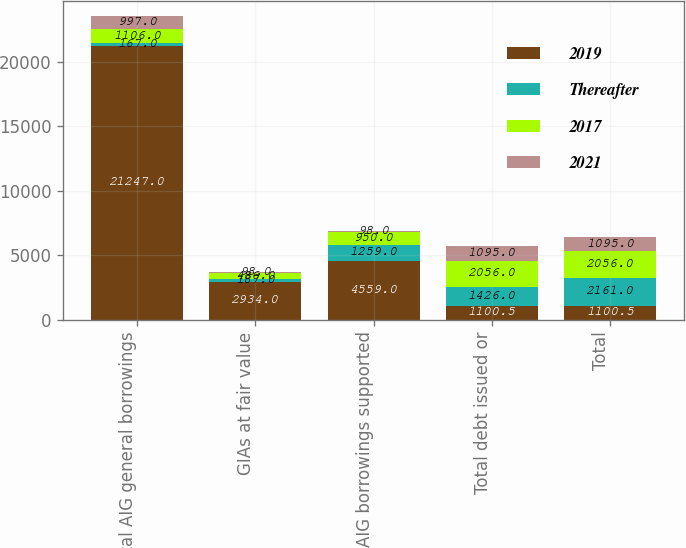Convert chart. <chart><loc_0><loc_0><loc_500><loc_500><stacked_bar_chart><ecel><fcel>Total AIG general borrowings<fcel>GIAs at fair value<fcel>Total AIG borrowings supported<fcel>Total debt issued or<fcel>Total<nl><fcel>2019<fcel>21247<fcel>2934<fcel>4559<fcel>1100.5<fcel>1100.5<nl><fcel>Thereafter<fcel>167<fcel>187<fcel>1259<fcel>1426<fcel>2161<nl><fcel>2017<fcel>1106<fcel>486<fcel>950<fcel>2056<fcel>2056<nl><fcel>2021<fcel>997<fcel>98<fcel>98<fcel>1095<fcel>1095<nl></chart> 